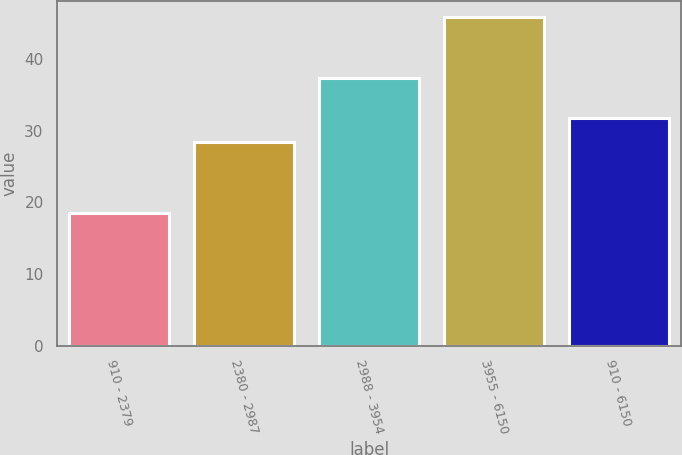Convert chart. <chart><loc_0><loc_0><loc_500><loc_500><bar_chart><fcel>910 - 2379<fcel>2380 - 2987<fcel>2988 - 3954<fcel>3955 - 6150<fcel>910 - 6150<nl><fcel>18.54<fcel>28.39<fcel>37.4<fcel>45.82<fcel>31.74<nl></chart> 